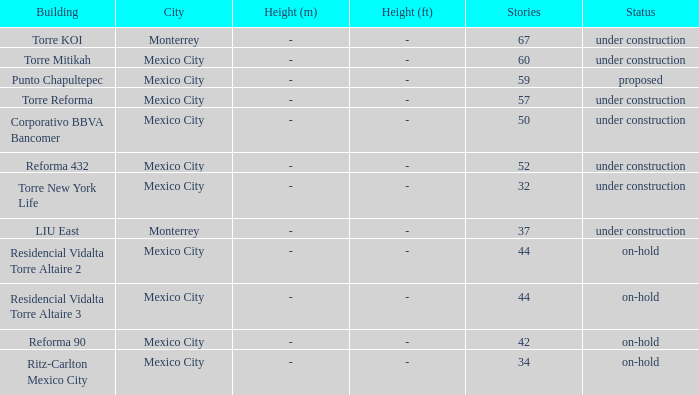What's the situation regarding the 44-story torre reforma building in mexico city? Under construction. 